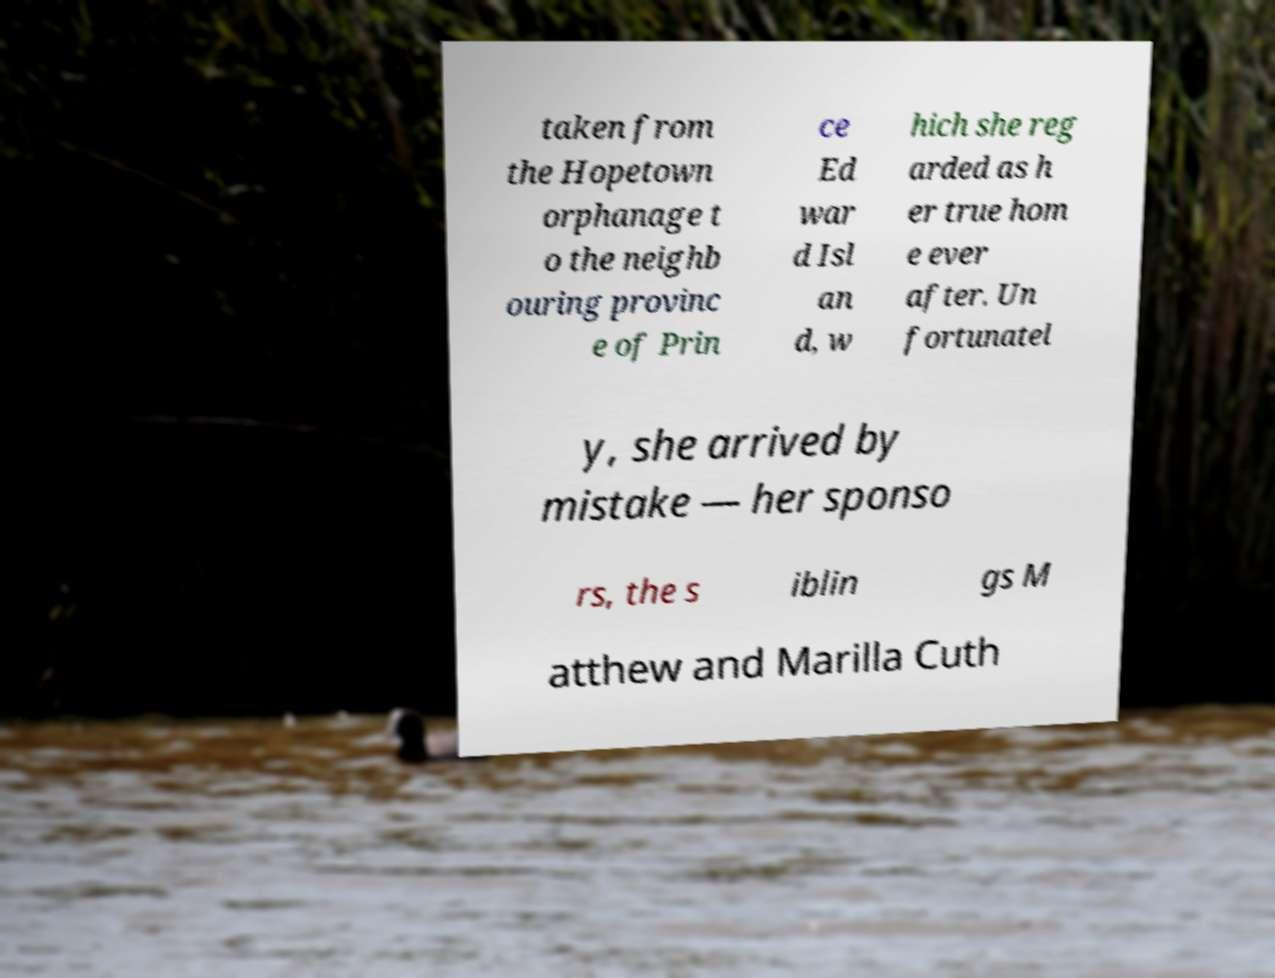Please identify and transcribe the text found in this image. taken from the Hopetown orphanage t o the neighb ouring provinc e of Prin ce Ed war d Isl an d, w hich she reg arded as h er true hom e ever after. Un fortunatel y, she arrived by mistake — her sponso rs, the s iblin gs M atthew and Marilla Cuth 